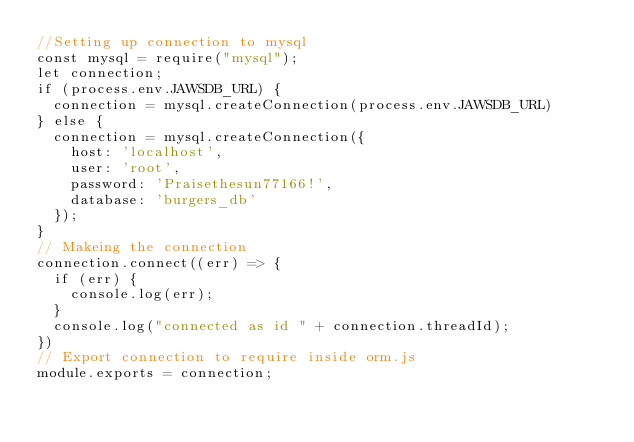Convert code to text. <code><loc_0><loc_0><loc_500><loc_500><_JavaScript_>//Setting up connection to mysql
const mysql = require("mysql");
let connection;
if (process.env.JAWSDB_URL) {
  connection = mysql.createConnection(process.env.JAWSDB_URL)
} else {
  connection = mysql.createConnection({
    host: 'localhost',
    user: 'root',
    password: 'Praisethesun77166!',
    database: 'burgers_db'
  });
}
// Makeing the connection
connection.connect((err) => {
  if (err) {
    console.log(err);
  }
  console.log("connected as id " + connection.threadId);
})
// Export connection to require inside orm.js
module.exports = connection;</code> 